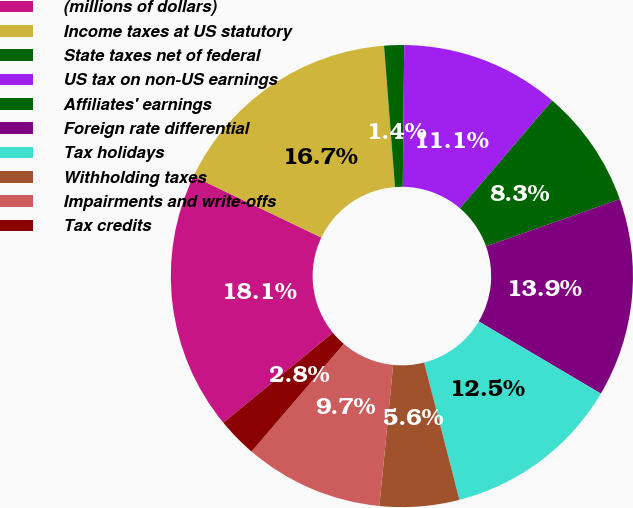Convert chart to OTSL. <chart><loc_0><loc_0><loc_500><loc_500><pie_chart><fcel>(millions of dollars)<fcel>Income taxes at US statutory<fcel>State taxes net of federal<fcel>US tax on non-US earnings<fcel>Affiliates' earnings<fcel>Foreign rate differential<fcel>Tax holidays<fcel>Withholding taxes<fcel>Impairments and write-offs<fcel>Tax credits<nl><fcel>18.05%<fcel>16.66%<fcel>1.39%<fcel>11.11%<fcel>8.33%<fcel>13.89%<fcel>12.5%<fcel>5.56%<fcel>9.72%<fcel>2.78%<nl></chart> 